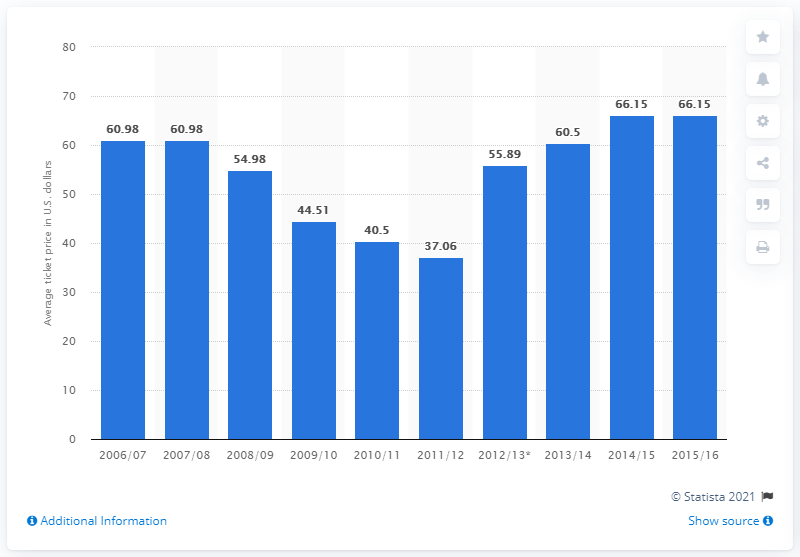Draw attention to some important aspects in this diagram. The average ticket price for the 2006/07 season was 60.98. 